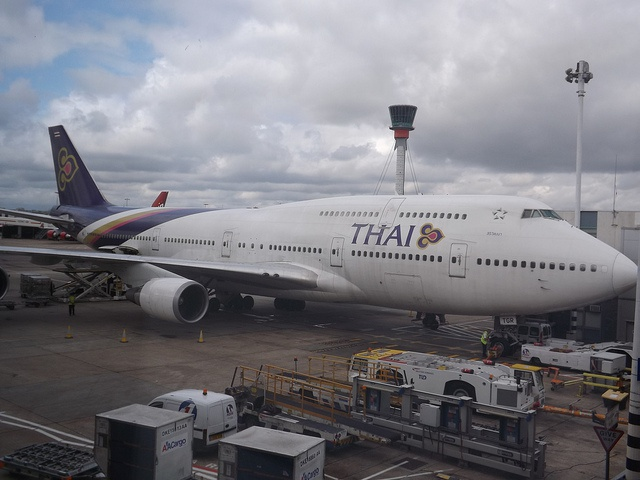Describe the objects in this image and their specific colors. I can see airplane in gray, darkgray, black, and lightgray tones, truck in gray, black, and maroon tones, truck in gray, black, maroon, and olive tones, people in gray, black, darkgreen, and olive tones, and people in black, darkgreen, and gray tones in this image. 